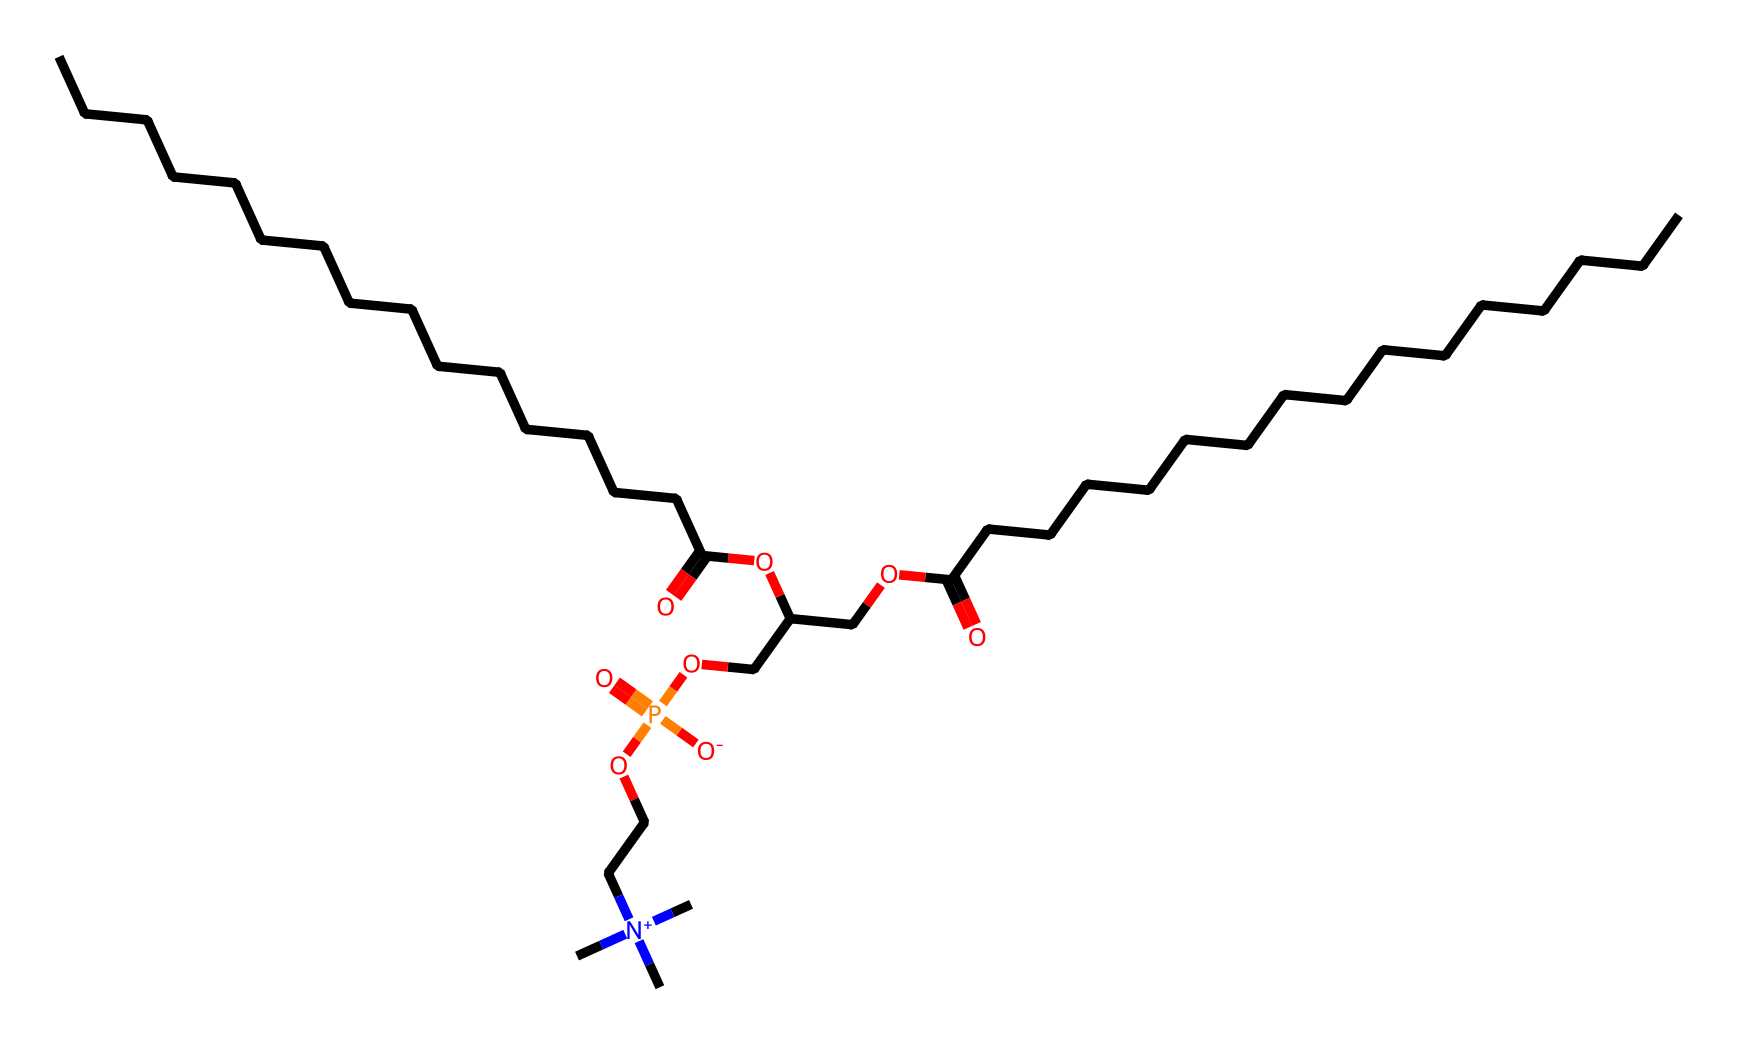What is the length of the longest carbon chain in this molecule? The longest carbon chain can be identified visually by finding the continuous sequence of carbon atoms without interruption. In this case, there are multiple long linear alkyl chains, but one stands out with 16 carbon atoms.
Answer: 16 How many nitrogen atoms are in the structure? By examining the SMILES representation, we can count the nitrogen atoms present. There are two nitrogen atoms indicated by the '[N+]' notation in the chemical structure.
Answer: 2 What is the oxidation state of phosphorus in this compound? The oxidation state can be deduced from the functional groups surrounding the phosphorus atom. Since phosphorus is bonded to four oxygens (including a double bond) and carries a negative charge within the structure, the oxidation state of phosphorus is +5.
Answer: +5 How many ester functional groups are in the molecule? An ester functional group can be identified by the presence of a carbonyl (C=O) bonded to an alkoxy group (–O–R). In the given structure, there are two ester linkages, which we can determine by identifying the carbonyls followed by ether oxygen connections.
Answer: 2 What distinguishes phospholipids from traditional fats? Phospholipids are characterized by the presence of a phosphate group attached to a glycerol backbone, along with fatty acid chains. In the provided SMILES, the presence of the phosphorus atom linked to the oxygen connects this to the lipid structure, setting it apart from traditional triglycerides which lack phosphorus.
Answer: phosphate group What type of interaction would this phospholipid have with water? Phospholipids exhibit amphipathic characteristics due to their hydrophilic head (the phosphate group) and hydrophobic tails (fatty acid chains). This dual nature leads to the formation of bilayers, making them uniquely suited for cell membrane formation, where the phosphate allows interaction with water while the fatty acids repel it.
Answer: amphipathic 